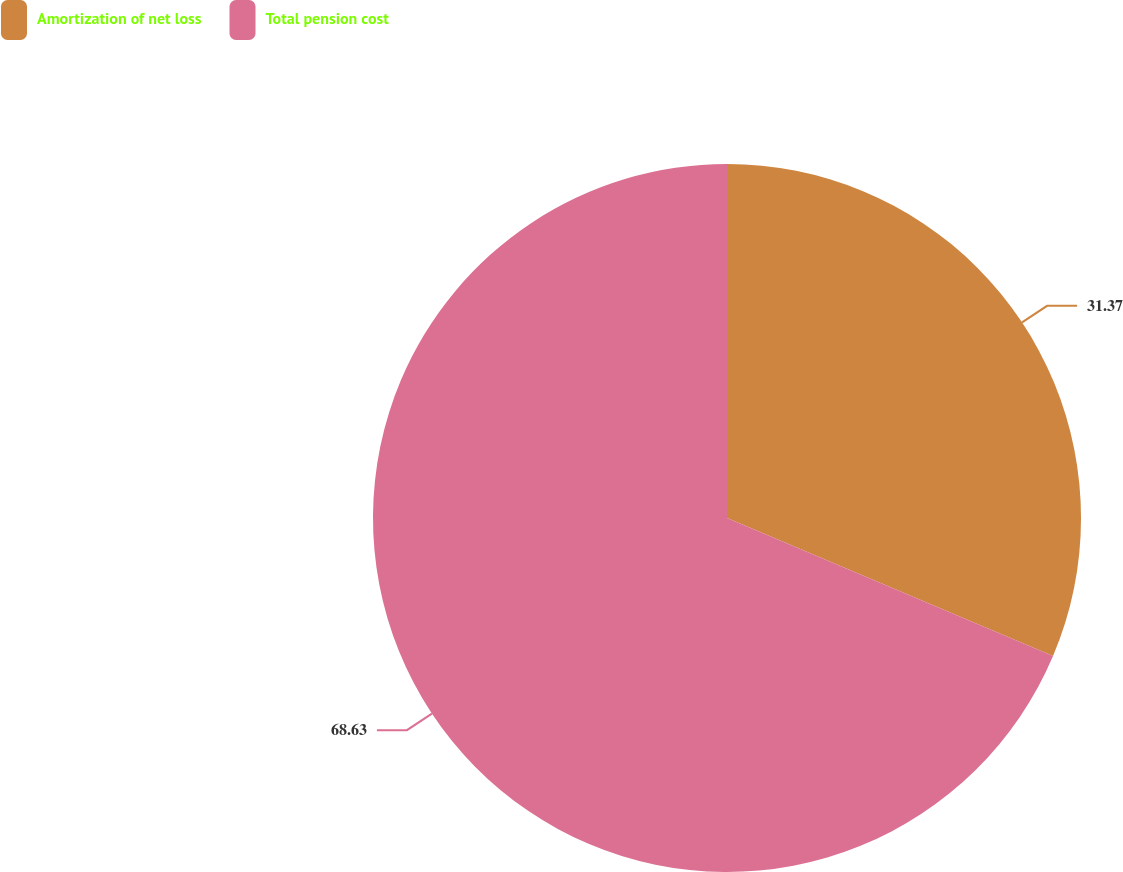Convert chart. <chart><loc_0><loc_0><loc_500><loc_500><pie_chart><fcel>Amortization of net loss<fcel>Total pension cost<nl><fcel>31.37%<fcel>68.63%<nl></chart> 